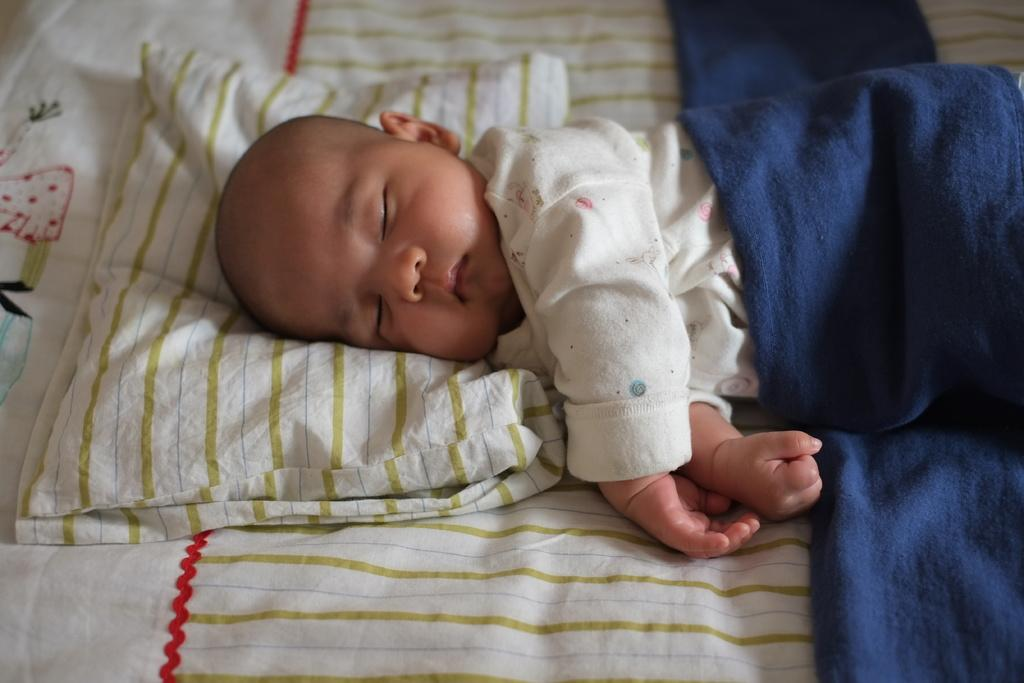Who is the main subject in the image? There is a child in the image. What is the child doing in the image? The child is lying on a bed. What can be seen on the bed besides the child? There is a pillow in the image. What color is the blanket that covers the child? There is a blue color blanket in the image. What type of rail can be seen near the child in the image? There is no rail present near the child in the image. What color is the child's skin in the image? The color of the child's skin cannot be determined from the image, as it does not provide information about skin color. 